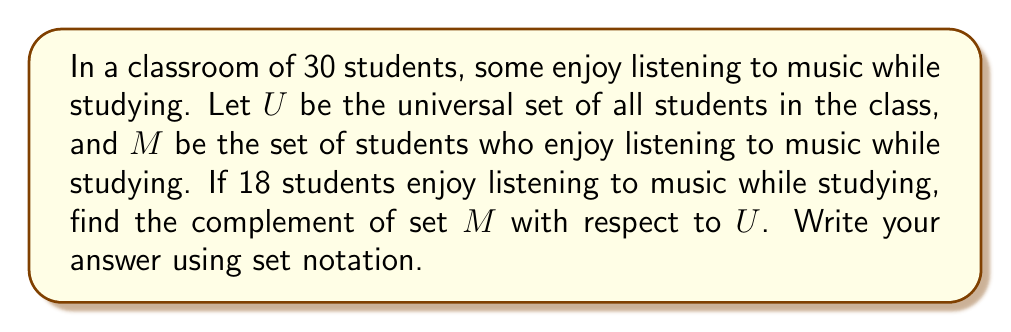Could you help me with this problem? Let's approach this step-by-step:

1) First, let's define our sets:
   $U$ = {all students in the class}
   $M$ = {students who enjoy listening to music while studying}

2) We're given that:
   $|U| = 30$ (total number of students)
   $|M| = 18$ (number of students who enjoy listening to music)

3) The complement of set $M$ with respect to $U$, denoted as $M^c$ or $U \setminus M$, is the set of all elements in $U$ that are not in $M$.

4) To find $M^c$, we need to subtract the elements in $M$ from $U$:
   $|M^c| = |U| - |M|$
   $|M^c| = 30 - 18 = 12$

5) This means that 12 students do not enjoy listening to music while studying.

6) To write this in set notation, we use:
   $M^c = \{x \in U : x \notin M\}$

   This reads as "The set of all elements $x$ in $U$ such that $x$ is not in $M$".
Answer: $M^c = \{x \in U : x \notin M\}$ 